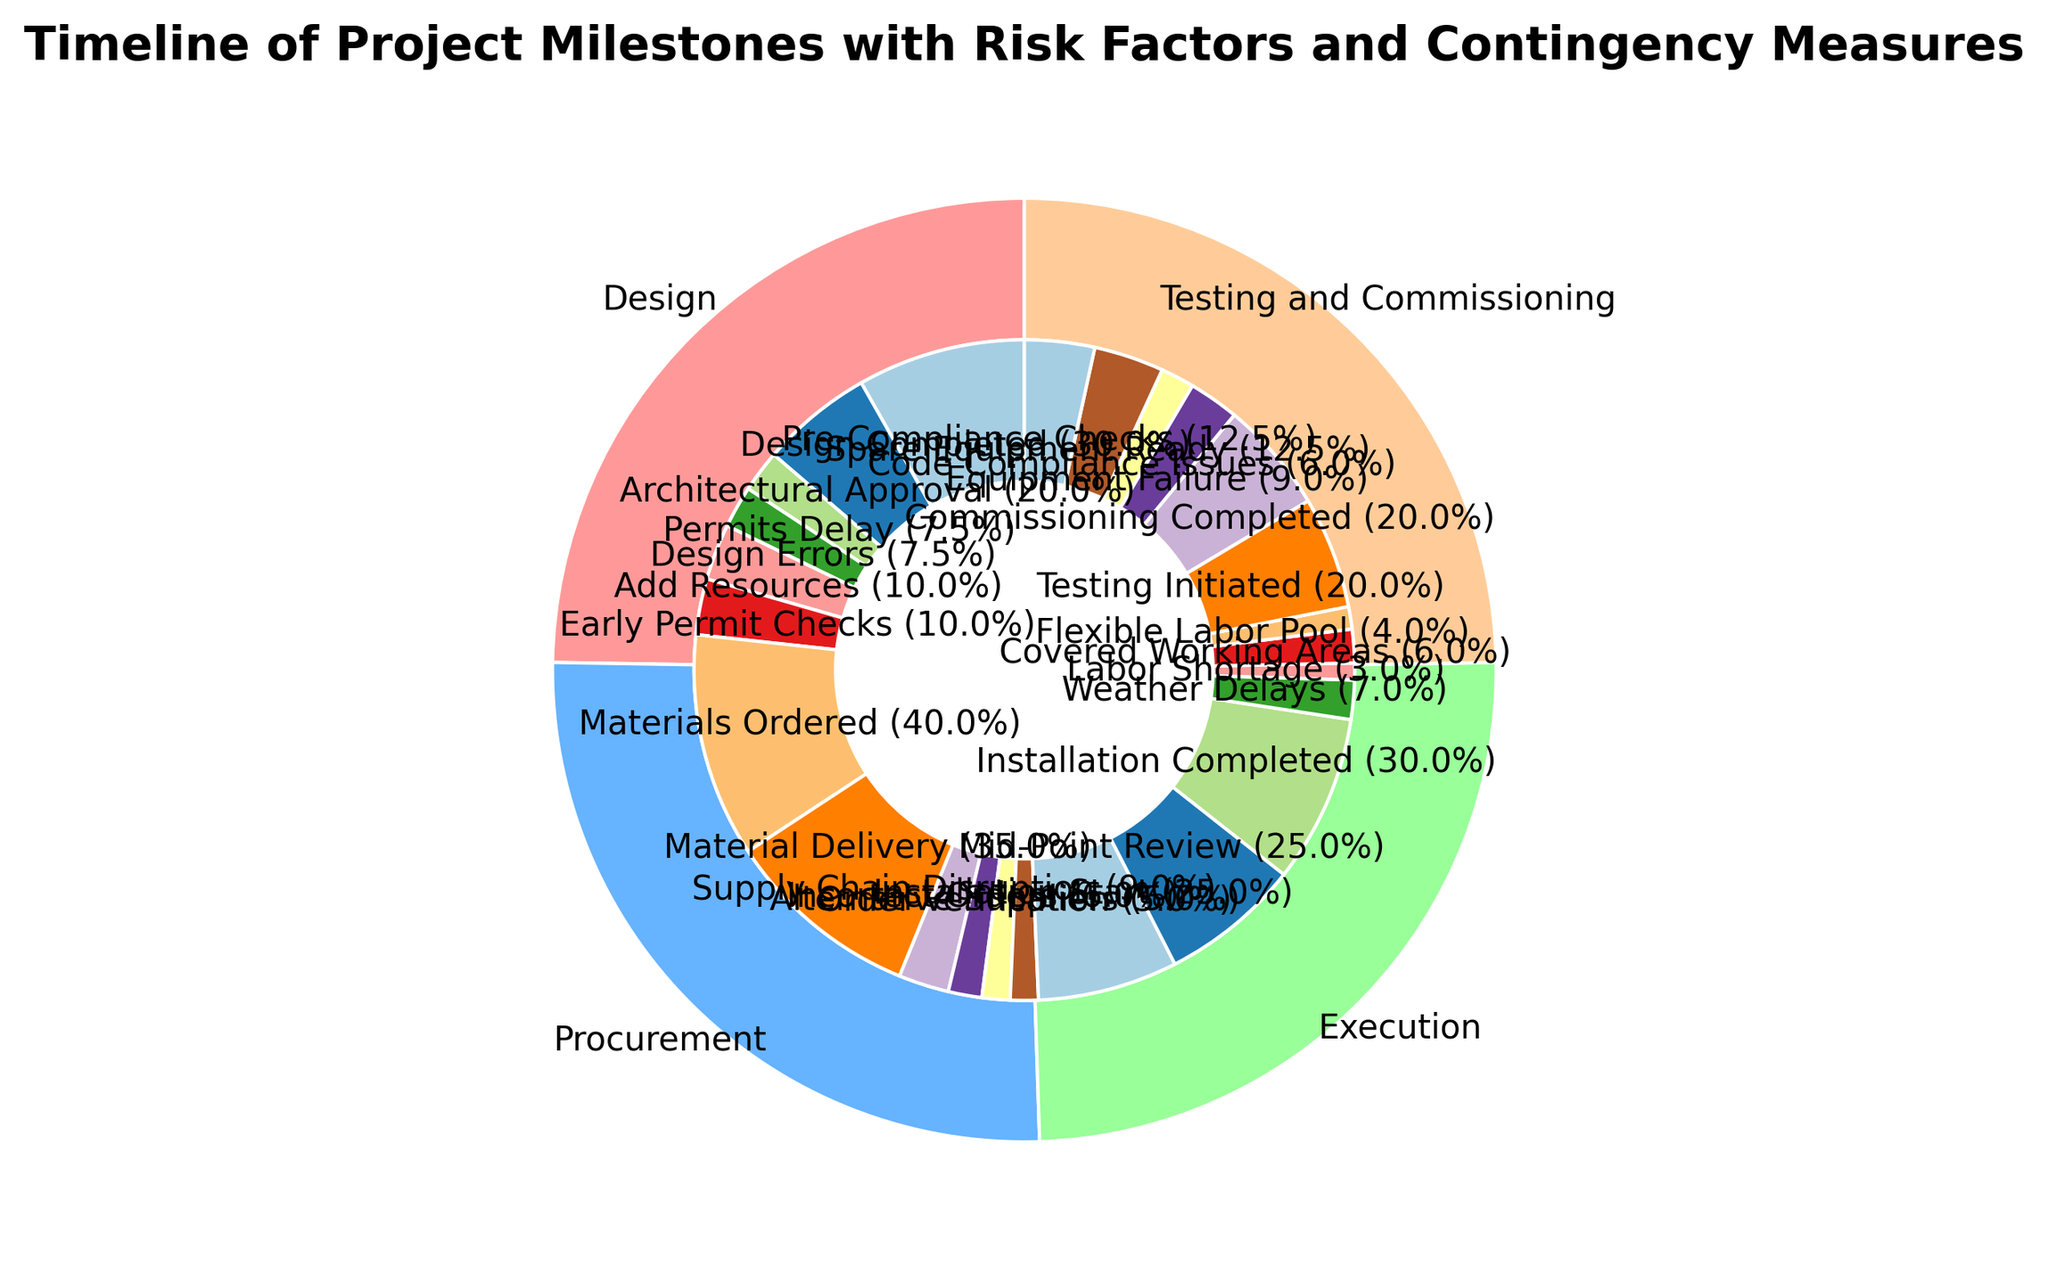What phase has the highest total percentage? Assess the outer pie chart; the largest wedge is for the "Design" phase.
Answer: Design Which phase's risk factor percentage is composed mostly of "Permits Delay"? Look at the inner pie chart for the "Design" phase; "Permits Delay" occupies half of the risk factor percentage.
Answer: Design How does the percentage of "Equipment Failure" as a risk factor in the Testing and Commissioning phase compare to "Weather Delays" in the Execution phase? Check the inner categories for both phases: "Equipment Failure" has 15% * 60% = 9% of the Testing and Commissioning phase, while "Weather Delays" has 10% * 70% = 7% of the Execution phase. Thus, Equipment Failure has a larger percentage.
Answer: Equipment Failure is larger What is the combined percentage of the "Materials Ordered" and "Material Delivery" milestones in the Procurement phase? Add the percentages of "Materials Ordered" (40%) and "Material Delivery" (35%) from the inner pie chart for Procurement.
Answer: 75% Which contingency measure has the greatest sub-percentage in the Testing and Commissioning phase? Examine Testing and Commissioning phase's contingencies in the inner pie chart; "Pre-Compliance Checks" and "Spare Equipment Ready" both share the highest sub-percentage of 50%.
Answer: Spare Equipment Ready, Pre-Compliance Checks (tie) If "Flexible Labor Pool" was increased by 5% and "Covered Working Areas" was decreased by 5%, which would then have a higher percentage in the Execution phase? Determine the current percentages: "Flexible Labor Pool" is 10% * 40% = 4%, "Covered Working Areas" is 10% * 60% = 6%. After adjustment: "Flexible Labor Pool" = 9%, "Covered Working Areas" = 1%.
Answer: Flexible Labor Pool What is the visual difference in color between "Risk Factors" and "Contingency Measures" in any given phase? Observe the inner pie segment colors: Risk Factors use shades different from the shades assigned to Contingency Measures.
Answer: Different color shades What is the overall percentage contribution of milestones during the Execution phase? Sum the milestone percentages in the Execution phase: 25% (Installation Start) + 25% (Mid-Point Review) + 30% (Installation Completed) = 80%.
Answer: 80% 